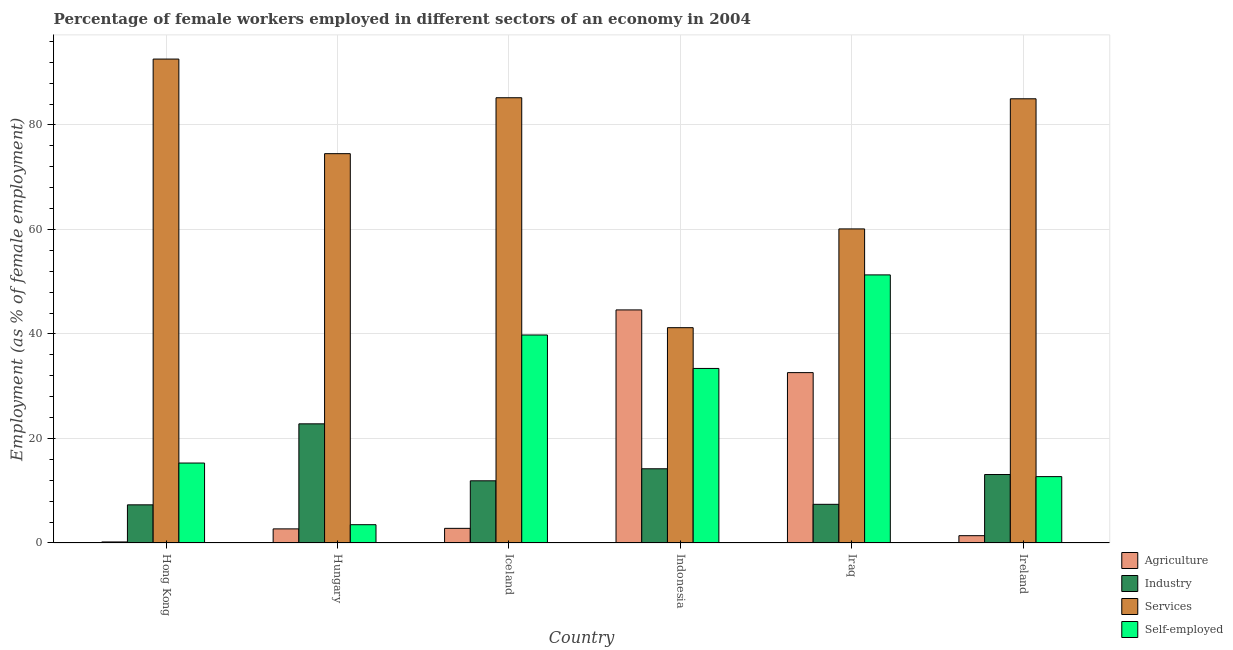How many different coloured bars are there?
Provide a short and direct response. 4. How many groups of bars are there?
Provide a succinct answer. 6. Are the number of bars on each tick of the X-axis equal?
Make the answer very short. Yes. How many bars are there on the 1st tick from the left?
Make the answer very short. 4. What is the label of the 1st group of bars from the left?
Give a very brief answer. Hong Kong. What is the percentage of female workers in agriculture in Hungary?
Offer a terse response. 2.7. Across all countries, what is the maximum percentage of female workers in industry?
Give a very brief answer. 22.8. Across all countries, what is the minimum percentage of female workers in services?
Provide a short and direct response. 41.2. In which country was the percentage of self employed female workers maximum?
Your answer should be compact. Iraq. In which country was the percentage of female workers in agriculture minimum?
Provide a succinct answer. Hong Kong. What is the total percentage of self employed female workers in the graph?
Keep it short and to the point. 156. What is the difference between the percentage of female workers in agriculture in Hungary and that in Ireland?
Offer a terse response. 1.3. What is the difference between the percentage of female workers in agriculture in Indonesia and the percentage of self employed female workers in Hungary?
Provide a succinct answer. 41.1. What is the average percentage of female workers in services per country?
Offer a very short reply. 73.1. What is the difference between the percentage of female workers in agriculture and percentage of self employed female workers in Iraq?
Provide a short and direct response. -18.7. In how many countries, is the percentage of female workers in services greater than 80 %?
Your response must be concise. 3. What is the ratio of the percentage of female workers in agriculture in Indonesia to that in Ireland?
Your answer should be very brief. 31.86. What is the difference between the highest and the lowest percentage of female workers in services?
Provide a short and direct response. 51.4. What does the 1st bar from the left in Ireland represents?
Offer a very short reply. Agriculture. What does the 3rd bar from the right in Ireland represents?
Offer a terse response. Industry. Is it the case that in every country, the sum of the percentage of female workers in agriculture and percentage of female workers in industry is greater than the percentage of female workers in services?
Provide a succinct answer. No. Are all the bars in the graph horizontal?
Provide a succinct answer. No. How many countries are there in the graph?
Your answer should be very brief. 6. What is the difference between two consecutive major ticks on the Y-axis?
Offer a terse response. 20. Are the values on the major ticks of Y-axis written in scientific E-notation?
Make the answer very short. No. Does the graph contain any zero values?
Your answer should be very brief. No. How many legend labels are there?
Offer a terse response. 4. How are the legend labels stacked?
Offer a very short reply. Vertical. What is the title of the graph?
Your answer should be compact. Percentage of female workers employed in different sectors of an economy in 2004. Does "Permission" appear as one of the legend labels in the graph?
Give a very brief answer. No. What is the label or title of the X-axis?
Offer a very short reply. Country. What is the label or title of the Y-axis?
Provide a succinct answer. Employment (as % of female employment). What is the Employment (as % of female employment) in Agriculture in Hong Kong?
Your answer should be compact. 0.2. What is the Employment (as % of female employment) of Industry in Hong Kong?
Offer a terse response. 7.3. What is the Employment (as % of female employment) in Services in Hong Kong?
Offer a terse response. 92.6. What is the Employment (as % of female employment) in Self-employed in Hong Kong?
Offer a terse response. 15.3. What is the Employment (as % of female employment) of Agriculture in Hungary?
Your answer should be compact. 2.7. What is the Employment (as % of female employment) in Industry in Hungary?
Keep it short and to the point. 22.8. What is the Employment (as % of female employment) in Services in Hungary?
Make the answer very short. 74.5. What is the Employment (as % of female employment) in Self-employed in Hungary?
Provide a succinct answer. 3.5. What is the Employment (as % of female employment) in Agriculture in Iceland?
Offer a terse response. 2.8. What is the Employment (as % of female employment) in Industry in Iceland?
Provide a short and direct response. 11.9. What is the Employment (as % of female employment) of Services in Iceland?
Keep it short and to the point. 85.2. What is the Employment (as % of female employment) of Self-employed in Iceland?
Offer a terse response. 39.8. What is the Employment (as % of female employment) in Agriculture in Indonesia?
Your answer should be compact. 44.6. What is the Employment (as % of female employment) of Industry in Indonesia?
Provide a succinct answer. 14.2. What is the Employment (as % of female employment) of Services in Indonesia?
Offer a very short reply. 41.2. What is the Employment (as % of female employment) in Self-employed in Indonesia?
Give a very brief answer. 33.4. What is the Employment (as % of female employment) of Agriculture in Iraq?
Offer a terse response. 32.6. What is the Employment (as % of female employment) of Industry in Iraq?
Provide a short and direct response. 7.4. What is the Employment (as % of female employment) in Services in Iraq?
Provide a short and direct response. 60.1. What is the Employment (as % of female employment) of Self-employed in Iraq?
Ensure brevity in your answer.  51.3. What is the Employment (as % of female employment) in Agriculture in Ireland?
Your response must be concise. 1.4. What is the Employment (as % of female employment) in Industry in Ireland?
Keep it short and to the point. 13.1. What is the Employment (as % of female employment) in Services in Ireland?
Your answer should be very brief. 85. What is the Employment (as % of female employment) in Self-employed in Ireland?
Your answer should be compact. 12.7. Across all countries, what is the maximum Employment (as % of female employment) of Agriculture?
Make the answer very short. 44.6. Across all countries, what is the maximum Employment (as % of female employment) of Industry?
Keep it short and to the point. 22.8. Across all countries, what is the maximum Employment (as % of female employment) of Services?
Your answer should be very brief. 92.6. Across all countries, what is the maximum Employment (as % of female employment) of Self-employed?
Keep it short and to the point. 51.3. Across all countries, what is the minimum Employment (as % of female employment) of Agriculture?
Your response must be concise. 0.2. Across all countries, what is the minimum Employment (as % of female employment) in Industry?
Provide a succinct answer. 7.3. Across all countries, what is the minimum Employment (as % of female employment) of Services?
Your answer should be compact. 41.2. What is the total Employment (as % of female employment) of Agriculture in the graph?
Offer a terse response. 84.3. What is the total Employment (as % of female employment) of Industry in the graph?
Provide a succinct answer. 76.7. What is the total Employment (as % of female employment) in Services in the graph?
Your answer should be compact. 438.6. What is the total Employment (as % of female employment) of Self-employed in the graph?
Give a very brief answer. 156. What is the difference between the Employment (as % of female employment) of Agriculture in Hong Kong and that in Hungary?
Provide a succinct answer. -2.5. What is the difference between the Employment (as % of female employment) of Industry in Hong Kong and that in Hungary?
Offer a very short reply. -15.5. What is the difference between the Employment (as % of female employment) in Agriculture in Hong Kong and that in Iceland?
Make the answer very short. -2.6. What is the difference between the Employment (as % of female employment) of Services in Hong Kong and that in Iceland?
Make the answer very short. 7.4. What is the difference between the Employment (as % of female employment) in Self-employed in Hong Kong and that in Iceland?
Offer a terse response. -24.5. What is the difference between the Employment (as % of female employment) of Agriculture in Hong Kong and that in Indonesia?
Provide a succinct answer. -44.4. What is the difference between the Employment (as % of female employment) of Services in Hong Kong and that in Indonesia?
Provide a succinct answer. 51.4. What is the difference between the Employment (as % of female employment) of Self-employed in Hong Kong and that in Indonesia?
Provide a succinct answer. -18.1. What is the difference between the Employment (as % of female employment) in Agriculture in Hong Kong and that in Iraq?
Keep it short and to the point. -32.4. What is the difference between the Employment (as % of female employment) in Industry in Hong Kong and that in Iraq?
Make the answer very short. -0.1. What is the difference between the Employment (as % of female employment) in Services in Hong Kong and that in Iraq?
Your response must be concise. 32.5. What is the difference between the Employment (as % of female employment) of Self-employed in Hong Kong and that in Iraq?
Keep it short and to the point. -36. What is the difference between the Employment (as % of female employment) in Agriculture in Hong Kong and that in Ireland?
Your response must be concise. -1.2. What is the difference between the Employment (as % of female employment) in Industry in Hong Kong and that in Ireland?
Offer a very short reply. -5.8. What is the difference between the Employment (as % of female employment) in Services in Hong Kong and that in Ireland?
Ensure brevity in your answer.  7.6. What is the difference between the Employment (as % of female employment) of Self-employed in Hong Kong and that in Ireland?
Provide a succinct answer. 2.6. What is the difference between the Employment (as % of female employment) in Industry in Hungary and that in Iceland?
Ensure brevity in your answer.  10.9. What is the difference between the Employment (as % of female employment) of Self-employed in Hungary and that in Iceland?
Offer a very short reply. -36.3. What is the difference between the Employment (as % of female employment) of Agriculture in Hungary and that in Indonesia?
Your answer should be very brief. -41.9. What is the difference between the Employment (as % of female employment) of Industry in Hungary and that in Indonesia?
Give a very brief answer. 8.6. What is the difference between the Employment (as % of female employment) in Services in Hungary and that in Indonesia?
Give a very brief answer. 33.3. What is the difference between the Employment (as % of female employment) of Self-employed in Hungary and that in Indonesia?
Your response must be concise. -29.9. What is the difference between the Employment (as % of female employment) in Agriculture in Hungary and that in Iraq?
Your answer should be very brief. -29.9. What is the difference between the Employment (as % of female employment) of Services in Hungary and that in Iraq?
Your answer should be compact. 14.4. What is the difference between the Employment (as % of female employment) of Self-employed in Hungary and that in Iraq?
Provide a succinct answer. -47.8. What is the difference between the Employment (as % of female employment) of Agriculture in Hungary and that in Ireland?
Give a very brief answer. 1.3. What is the difference between the Employment (as % of female employment) of Industry in Hungary and that in Ireland?
Ensure brevity in your answer.  9.7. What is the difference between the Employment (as % of female employment) in Agriculture in Iceland and that in Indonesia?
Provide a succinct answer. -41.8. What is the difference between the Employment (as % of female employment) in Industry in Iceland and that in Indonesia?
Keep it short and to the point. -2.3. What is the difference between the Employment (as % of female employment) in Services in Iceland and that in Indonesia?
Keep it short and to the point. 44. What is the difference between the Employment (as % of female employment) in Self-employed in Iceland and that in Indonesia?
Make the answer very short. 6.4. What is the difference between the Employment (as % of female employment) in Agriculture in Iceland and that in Iraq?
Offer a terse response. -29.8. What is the difference between the Employment (as % of female employment) in Services in Iceland and that in Iraq?
Your answer should be compact. 25.1. What is the difference between the Employment (as % of female employment) in Self-employed in Iceland and that in Iraq?
Offer a very short reply. -11.5. What is the difference between the Employment (as % of female employment) of Self-employed in Iceland and that in Ireland?
Keep it short and to the point. 27.1. What is the difference between the Employment (as % of female employment) in Services in Indonesia and that in Iraq?
Provide a short and direct response. -18.9. What is the difference between the Employment (as % of female employment) of Self-employed in Indonesia and that in Iraq?
Offer a terse response. -17.9. What is the difference between the Employment (as % of female employment) in Agriculture in Indonesia and that in Ireland?
Give a very brief answer. 43.2. What is the difference between the Employment (as % of female employment) of Industry in Indonesia and that in Ireland?
Keep it short and to the point. 1.1. What is the difference between the Employment (as % of female employment) in Services in Indonesia and that in Ireland?
Your answer should be very brief. -43.8. What is the difference between the Employment (as % of female employment) of Self-employed in Indonesia and that in Ireland?
Your answer should be very brief. 20.7. What is the difference between the Employment (as % of female employment) in Agriculture in Iraq and that in Ireland?
Your response must be concise. 31.2. What is the difference between the Employment (as % of female employment) of Industry in Iraq and that in Ireland?
Offer a very short reply. -5.7. What is the difference between the Employment (as % of female employment) in Services in Iraq and that in Ireland?
Provide a short and direct response. -24.9. What is the difference between the Employment (as % of female employment) of Self-employed in Iraq and that in Ireland?
Your answer should be very brief. 38.6. What is the difference between the Employment (as % of female employment) in Agriculture in Hong Kong and the Employment (as % of female employment) in Industry in Hungary?
Ensure brevity in your answer.  -22.6. What is the difference between the Employment (as % of female employment) in Agriculture in Hong Kong and the Employment (as % of female employment) in Services in Hungary?
Keep it short and to the point. -74.3. What is the difference between the Employment (as % of female employment) in Industry in Hong Kong and the Employment (as % of female employment) in Services in Hungary?
Keep it short and to the point. -67.2. What is the difference between the Employment (as % of female employment) in Industry in Hong Kong and the Employment (as % of female employment) in Self-employed in Hungary?
Give a very brief answer. 3.8. What is the difference between the Employment (as % of female employment) of Services in Hong Kong and the Employment (as % of female employment) of Self-employed in Hungary?
Give a very brief answer. 89.1. What is the difference between the Employment (as % of female employment) of Agriculture in Hong Kong and the Employment (as % of female employment) of Industry in Iceland?
Your response must be concise. -11.7. What is the difference between the Employment (as % of female employment) of Agriculture in Hong Kong and the Employment (as % of female employment) of Services in Iceland?
Your answer should be compact. -85. What is the difference between the Employment (as % of female employment) in Agriculture in Hong Kong and the Employment (as % of female employment) in Self-employed in Iceland?
Your answer should be compact. -39.6. What is the difference between the Employment (as % of female employment) of Industry in Hong Kong and the Employment (as % of female employment) of Services in Iceland?
Provide a succinct answer. -77.9. What is the difference between the Employment (as % of female employment) of Industry in Hong Kong and the Employment (as % of female employment) of Self-employed in Iceland?
Ensure brevity in your answer.  -32.5. What is the difference between the Employment (as % of female employment) of Services in Hong Kong and the Employment (as % of female employment) of Self-employed in Iceland?
Offer a very short reply. 52.8. What is the difference between the Employment (as % of female employment) in Agriculture in Hong Kong and the Employment (as % of female employment) in Services in Indonesia?
Ensure brevity in your answer.  -41. What is the difference between the Employment (as % of female employment) in Agriculture in Hong Kong and the Employment (as % of female employment) in Self-employed in Indonesia?
Give a very brief answer. -33.2. What is the difference between the Employment (as % of female employment) of Industry in Hong Kong and the Employment (as % of female employment) of Services in Indonesia?
Your answer should be compact. -33.9. What is the difference between the Employment (as % of female employment) of Industry in Hong Kong and the Employment (as % of female employment) of Self-employed in Indonesia?
Your answer should be compact. -26.1. What is the difference between the Employment (as % of female employment) in Services in Hong Kong and the Employment (as % of female employment) in Self-employed in Indonesia?
Your answer should be very brief. 59.2. What is the difference between the Employment (as % of female employment) in Agriculture in Hong Kong and the Employment (as % of female employment) in Services in Iraq?
Offer a very short reply. -59.9. What is the difference between the Employment (as % of female employment) of Agriculture in Hong Kong and the Employment (as % of female employment) of Self-employed in Iraq?
Your answer should be very brief. -51.1. What is the difference between the Employment (as % of female employment) in Industry in Hong Kong and the Employment (as % of female employment) in Services in Iraq?
Offer a terse response. -52.8. What is the difference between the Employment (as % of female employment) of Industry in Hong Kong and the Employment (as % of female employment) of Self-employed in Iraq?
Provide a succinct answer. -44. What is the difference between the Employment (as % of female employment) in Services in Hong Kong and the Employment (as % of female employment) in Self-employed in Iraq?
Make the answer very short. 41.3. What is the difference between the Employment (as % of female employment) in Agriculture in Hong Kong and the Employment (as % of female employment) in Services in Ireland?
Make the answer very short. -84.8. What is the difference between the Employment (as % of female employment) in Agriculture in Hong Kong and the Employment (as % of female employment) in Self-employed in Ireland?
Your answer should be compact. -12.5. What is the difference between the Employment (as % of female employment) of Industry in Hong Kong and the Employment (as % of female employment) of Services in Ireland?
Give a very brief answer. -77.7. What is the difference between the Employment (as % of female employment) in Services in Hong Kong and the Employment (as % of female employment) in Self-employed in Ireland?
Provide a succinct answer. 79.9. What is the difference between the Employment (as % of female employment) in Agriculture in Hungary and the Employment (as % of female employment) in Services in Iceland?
Your answer should be very brief. -82.5. What is the difference between the Employment (as % of female employment) of Agriculture in Hungary and the Employment (as % of female employment) of Self-employed in Iceland?
Your response must be concise. -37.1. What is the difference between the Employment (as % of female employment) in Industry in Hungary and the Employment (as % of female employment) in Services in Iceland?
Ensure brevity in your answer.  -62.4. What is the difference between the Employment (as % of female employment) in Industry in Hungary and the Employment (as % of female employment) in Self-employed in Iceland?
Give a very brief answer. -17. What is the difference between the Employment (as % of female employment) in Services in Hungary and the Employment (as % of female employment) in Self-employed in Iceland?
Keep it short and to the point. 34.7. What is the difference between the Employment (as % of female employment) in Agriculture in Hungary and the Employment (as % of female employment) in Services in Indonesia?
Give a very brief answer. -38.5. What is the difference between the Employment (as % of female employment) in Agriculture in Hungary and the Employment (as % of female employment) in Self-employed in Indonesia?
Give a very brief answer. -30.7. What is the difference between the Employment (as % of female employment) of Industry in Hungary and the Employment (as % of female employment) of Services in Indonesia?
Your answer should be compact. -18.4. What is the difference between the Employment (as % of female employment) of Services in Hungary and the Employment (as % of female employment) of Self-employed in Indonesia?
Give a very brief answer. 41.1. What is the difference between the Employment (as % of female employment) in Agriculture in Hungary and the Employment (as % of female employment) in Services in Iraq?
Make the answer very short. -57.4. What is the difference between the Employment (as % of female employment) of Agriculture in Hungary and the Employment (as % of female employment) of Self-employed in Iraq?
Provide a short and direct response. -48.6. What is the difference between the Employment (as % of female employment) of Industry in Hungary and the Employment (as % of female employment) of Services in Iraq?
Offer a terse response. -37.3. What is the difference between the Employment (as % of female employment) of Industry in Hungary and the Employment (as % of female employment) of Self-employed in Iraq?
Provide a short and direct response. -28.5. What is the difference between the Employment (as % of female employment) of Services in Hungary and the Employment (as % of female employment) of Self-employed in Iraq?
Offer a very short reply. 23.2. What is the difference between the Employment (as % of female employment) in Agriculture in Hungary and the Employment (as % of female employment) in Industry in Ireland?
Offer a very short reply. -10.4. What is the difference between the Employment (as % of female employment) in Agriculture in Hungary and the Employment (as % of female employment) in Services in Ireland?
Your answer should be very brief. -82.3. What is the difference between the Employment (as % of female employment) of Agriculture in Hungary and the Employment (as % of female employment) of Self-employed in Ireland?
Offer a very short reply. -10. What is the difference between the Employment (as % of female employment) of Industry in Hungary and the Employment (as % of female employment) of Services in Ireland?
Your answer should be compact. -62.2. What is the difference between the Employment (as % of female employment) in Industry in Hungary and the Employment (as % of female employment) in Self-employed in Ireland?
Give a very brief answer. 10.1. What is the difference between the Employment (as % of female employment) in Services in Hungary and the Employment (as % of female employment) in Self-employed in Ireland?
Offer a terse response. 61.8. What is the difference between the Employment (as % of female employment) of Agriculture in Iceland and the Employment (as % of female employment) of Services in Indonesia?
Make the answer very short. -38.4. What is the difference between the Employment (as % of female employment) in Agriculture in Iceland and the Employment (as % of female employment) in Self-employed in Indonesia?
Make the answer very short. -30.6. What is the difference between the Employment (as % of female employment) of Industry in Iceland and the Employment (as % of female employment) of Services in Indonesia?
Ensure brevity in your answer.  -29.3. What is the difference between the Employment (as % of female employment) of Industry in Iceland and the Employment (as % of female employment) of Self-employed in Indonesia?
Ensure brevity in your answer.  -21.5. What is the difference between the Employment (as % of female employment) of Services in Iceland and the Employment (as % of female employment) of Self-employed in Indonesia?
Keep it short and to the point. 51.8. What is the difference between the Employment (as % of female employment) of Agriculture in Iceland and the Employment (as % of female employment) of Industry in Iraq?
Ensure brevity in your answer.  -4.6. What is the difference between the Employment (as % of female employment) in Agriculture in Iceland and the Employment (as % of female employment) in Services in Iraq?
Your answer should be compact. -57.3. What is the difference between the Employment (as % of female employment) of Agriculture in Iceland and the Employment (as % of female employment) of Self-employed in Iraq?
Offer a terse response. -48.5. What is the difference between the Employment (as % of female employment) of Industry in Iceland and the Employment (as % of female employment) of Services in Iraq?
Offer a terse response. -48.2. What is the difference between the Employment (as % of female employment) in Industry in Iceland and the Employment (as % of female employment) in Self-employed in Iraq?
Provide a succinct answer. -39.4. What is the difference between the Employment (as % of female employment) of Services in Iceland and the Employment (as % of female employment) of Self-employed in Iraq?
Provide a short and direct response. 33.9. What is the difference between the Employment (as % of female employment) of Agriculture in Iceland and the Employment (as % of female employment) of Industry in Ireland?
Provide a short and direct response. -10.3. What is the difference between the Employment (as % of female employment) of Agriculture in Iceland and the Employment (as % of female employment) of Services in Ireland?
Keep it short and to the point. -82.2. What is the difference between the Employment (as % of female employment) of Agriculture in Iceland and the Employment (as % of female employment) of Self-employed in Ireland?
Offer a very short reply. -9.9. What is the difference between the Employment (as % of female employment) in Industry in Iceland and the Employment (as % of female employment) in Services in Ireland?
Your response must be concise. -73.1. What is the difference between the Employment (as % of female employment) of Services in Iceland and the Employment (as % of female employment) of Self-employed in Ireland?
Offer a very short reply. 72.5. What is the difference between the Employment (as % of female employment) in Agriculture in Indonesia and the Employment (as % of female employment) in Industry in Iraq?
Make the answer very short. 37.2. What is the difference between the Employment (as % of female employment) in Agriculture in Indonesia and the Employment (as % of female employment) in Services in Iraq?
Provide a short and direct response. -15.5. What is the difference between the Employment (as % of female employment) in Industry in Indonesia and the Employment (as % of female employment) in Services in Iraq?
Give a very brief answer. -45.9. What is the difference between the Employment (as % of female employment) of Industry in Indonesia and the Employment (as % of female employment) of Self-employed in Iraq?
Make the answer very short. -37.1. What is the difference between the Employment (as % of female employment) in Services in Indonesia and the Employment (as % of female employment) in Self-employed in Iraq?
Give a very brief answer. -10.1. What is the difference between the Employment (as % of female employment) in Agriculture in Indonesia and the Employment (as % of female employment) in Industry in Ireland?
Your response must be concise. 31.5. What is the difference between the Employment (as % of female employment) in Agriculture in Indonesia and the Employment (as % of female employment) in Services in Ireland?
Provide a succinct answer. -40.4. What is the difference between the Employment (as % of female employment) of Agriculture in Indonesia and the Employment (as % of female employment) of Self-employed in Ireland?
Ensure brevity in your answer.  31.9. What is the difference between the Employment (as % of female employment) in Industry in Indonesia and the Employment (as % of female employment) in Services in Ireland?
Provide a short and direct response. -70.8. What is the difference between the Employment (as % of female employment) of Services in Indonesia and the Employment (as % of female employment) of Self-employed in Ireland?
Provide a succinct answer. 28.5. What is the difference between the Employment (as % of female employment) of Agriculture in Iraq and the Employment (as % of female employment) of Services in Ireland?
Ensure brevity in your answer.  -52.4. What is the difference between the Employment (as % of female employment) of Agriculture in Iraq and the Employment (as % of female employment) of Self-employed in Ireland?
Your response must be concise. 19.9. What is the difference between the Employment (as % of female employment) in Industry in Iraq and the Employment (as % of female employment) in Services in Ireland?
Offer a very short reply. -77.6. What is the difference between the Employment (as % of female employment) in Industry in Iraq and the Employment (as % of female employment) in Self-employed in Ireland?
Provide a succinct answer. -5.3. What is the difference between the Employment (as % of female employment) in Services in Iraq and the Employment (as % of female employment) in Self-employed in Ireland?
Offer a terse response. 47.4. What is the average Employment (as % of female employment) in Agriculture per country?
Give a very brief answer. 14.05. What is the average Employment (as % of female employment) of Industry per country?
Provide a short and direct response. 12.78. What is the average Employment (as % of female employment) in Services per country?
Make the answer very short. 73.1. What is the difference between the Employment (as % of female employment) in Agriculture and Employment (as % of female employment) in Services in Hong Kong?
Provide a succinct answer. -92.4. What is the difference between the Employment (as % of female employment) of Agriculture and Employment (as % of female employment) of Self-employed in Hong Kong?
Give a very brief answer. -15.1. What is the difference between the Employment (as % of female employment) in Industry and Employment (as % of female employment) in Services in Hong Kong?
Your answer should be compact. -85.3. What is the difference between the Employment (as % of female employment) of Industry and Employment (as % of female employment) of Self-employed in Hong Kong?
Keep it short and to the point. -8. What is the difference between the Employment (as % of female employment) in Services and Employment (as % of female employment) in Self-employed in Hong Kong?
Keep it short and to the point. 77.3. What is the difference between the Employment (as % of female employment) of Agriculture and Employment (as % of female employment) of Industry in Hungary?
Provide a succinct answer. -20.1. What is the difference between the Employment (as % of female employment) of Agriculture and Employment (as % of female employment) of Services in Hungary?
Provide a succinct answer. -71.8. What is the difference between the Employment (as % of female employment) of Agriculture and Employment (as % of female employment) of Self-employed in Hungary?
Keep it short and to the point. -0.8. What is the difference between the Employment (as % of female employment) in Industry and Employment (as % of female employment) in Services in Hungary?
Ensure brevity in your answer.  -51.7. What is the difference between the Employment (as % of female employment) of Industry and Employment (as % of female employment) of Self-employed in Hungary?
Your answer should be very brief. 19.3. What is the difference between the Employment (as % of female employment) of Agriculture and Employment (as % of female employment) of Industry in Iceland?
Your answer should be compact. -9.1. What is the difference between the Employment (as % of female employment) of Agriculture and Employment (as % of female employment) of Services in Iceland?
Offer a very short reply. -82.4. What is the difference between the Employment (as % of female employment) in Agriculture and Employment (as % of female employment) in Self-employed in Iceland?
Your answer should be compact. -37. What is the difference between the Employment (as % of female employment) of Industry and Employment (as % of female employment) of Services in Iceland?
Give a very brief answer. -73.3. What is the difference between the Employment (as % of female employment) in Industry and Employment (as % of female employment) in Self-employed in Iceland?
Make the answer very short. -27.9. What is the difference between the Employment (as % of female employment) of Services and Employment (as % of female employment) of Self-employed in Iceland?
Make the answer very short. 45.4. What is the difference between the Employment (as % of female employment) of Agriculture and Employment (as % of female employment) of Industry in Indonesia?
Offer a terse response. 30.4. What is the difference between the Employment (as % of female employment) of Agriculture and Employment (as % of female employment) of Services in Indonesia?
Offer a terse response. 3.4. What is the difference between the Employment (as % of female employment) of Agriculture and Employment (as % of female employment) of Self-employed in Indonesia?
Make the answer very short. 11.2. What is the difference between the Employment (as % of female employment) of Industry and Employment (as % of female employment) of Services in Indonesia?
Keep it short and to the point. -27. What is the difference between the Employment (as % of female employment) in Industry and Employment (as % of female employment) in Self-employed in Indonesia?
Keep it short and to the point. -19.2. What is the difference between the Employment (as % of female employment) in Services and Employment (as % of female employment) in Self-employed in Indonesia?
Ensure brevity in your answer.  7.8. What is the difference between the Employment (as % of female employment) of Agriculture and Employment (as % of female employment) of Industry in Iraq?
Offer a very short reply. 25.2. What is the difference between the Employment (as % of female employment) in Agriculture and Employment (as % of female employment) in Services in Iraq?
Provide a short and direct response. -27.5. What is the difference between the Employment (as % of female employment) of Agriculture and Employment (as % of female employment) of Self-employed in Iraq?
Your answer should be compact. -18.7. What is the difference between the Employment (as % of female employment) of Industry and Employment (as % of female employment) of Services in Iraq?
Offer a terse response. -52.7. What is the difference between the Employment (as % of female employment) of Industry and Employment (as % of female employment) of Self-employed in Iraq?
Offer a terse response. -43.9. What is the difference between the Employment (as % of female employment) of Services and Employment (as % of female employment) of Self-employed in Iraq?
Provide a succinct answer. 8.8. What is the difference between the Employment (as % of female employment) of Agriculture and Employment (as % of female employment) of Industry in Ireland?
Your response must be concise. -11.7. What is the difference between the Employment (as % of female employment) of Agriculture and Employment (as % of female employment) of Services in Ireland?
Your answer should be compact. -83.6. What is the difference between the Employment (as % of female employment) of Industry and Employment (as % of female employment) of Services in Ireland?
Your answer should be very brief. -71.9. What is the difference between the Employment (as % of female employment) of Industry and Employment (as % of female employment) of Self-employed in Ireland?
Offer a terse response. 0.4. What is the difference between the Employment (as % of female employment) in Services and Employment (as % of female employment) in Self-employed in Ireland?
Ensure brevity in your answer.  72.3. What is the ratio of the Employment (as % of female employment) of Agriculture in Hong Kong to that in Hungary?
Keep it short and to the point. 0.07. What is the ratio of the Employment (as % of female employment) of Industry in Hong Kong to that in Hungary?
Your response must be concise. 0.32. What is the ratio of the Employment (as % of female employment) of Services in Hong Kong to that in Hungary?
Provide a succinct answer. 1.24. What is the ratio of the Employment (as % of female employment) in Self-employed in Hong Kong to that in Hungary?
Your answer should be very brief. 4.37. What is the ratio of the Employment (as % of female employment) in Agriculture in Hong Kong to that in Iceland?
Ensure brevity in your answer.  0.07. What is the ratio of the Employment (as % of female employment) in Industry in Hong Kong to that in Iceland?
Your response must be concise. 0.61. What is the ratio of the Employment (as % of female employment) of Services in Hong Kong to that in Iceland?
Your answer should be very brief. 1.09. What is the ratio of the Employment (as % of female employment) of Self-employed in Hong Kong to that in Iceland?
Your answer should be compact. 0.38. What is the ratio of the Employment (as % of female employment) in Agriculture in Hong Kong to that in Indonesia?
Your response must be concise. 0. What is the ratio of the Employment (as % of female employment) of Industry in Hong Kong to that in Indonesia?
Your answer should be very brief. 0.51. What is the ratio of the Employment (as % of female employment) of Services in Hong Kong to that in Indonesia?
Ensure brevity in your answer.  2.25. What is the ratio of the Employment (as % of female employment) of Self-employed in Hong Kong to that in Indonesia?
Keep it short and to the point. 0.46. What is the ratio of the Employment (as % of female employment) of Agriculture in Hong Kong to that in Iraq?
Make the answer very short. 0.01. What is the ratio of the Employment (as % of female employment) in Industry in Hong Kong to that in Iraq?
Your answer should be very brief. 0.99. What is the ratio of the Employment (as % of female employment) in Services in Hong Kong to that in Iraq?
Offer a terse response. 1.54. What is the ratio of the Employment (as % of female employment) in Self-employed in Hong Kong to that in Iraq?
Offer a terse response. 0.3. What is the ratio of the Employment (as % of female employment) in Agriculture in Hong Kong to that in Ireland?
Your answer should be compact. 0.14. What is the ratio of the Employment (as % of female employment) of Industry in Hong Kong to that in Ireland?
Give a very brief answer. 0.56. What is the ratio of the Employment (as % of female employment) in Services in Hong Kong to that in Ireland?
Keep it short and to the point. 1.09. What is the ratio of the Employment (as % of female employment) in Self-employed in Hong Kong to that in Ireland?
Give a very brief answer. 1.2. What is the ratio of the Employment (as % of female employment) of Industry in Hungary to that in Iceland?
Provide a short and direct response. 1.92. What is the ratio of the Employment (as % of female employment) of Services in Hungary to that in Iceland?
Ensure brevity in your answer.  0.87. What is the ratio of the Employment (as % of female employment) in Self-employed in Hungary to that in Iceland?
Provide a succinct answer. 0.09. What is the ratio of the Employment (as % of female employment) of Agriculture in Hungary to that in Indonesia?
Provide a succinct answer. 0.06. What is the ratio of the Employment (as % of female employment) of Industry in Hungary to that in Indonesia?
Your answer should be compact. 1.61. What is the ratio of the Employment (as % of female employment) in Services in Hungary to that in Indonesia?
Give a very brief answer. 1.81. What is the ratio of the Employment (as % of female employment) in Self-employed in Hungary to that in Indonesia?
Keep it short and to the point. 0.1. What is the ratio of the Employment (as % of female employment) of Agriculture in Hungary to that in Iraq?
Your answer should be very brief. 0.08. What is the ratio of the Employment (as % of female employment) of Industry in Hungary to that in Iraq?
Your answer should be very brief. 3.08. What is the ratio of the Employment (as % of female employment) in Services in Hungary to that in Iraq?
Ensure brevity in your answer.  1.24. What is the ratio of the Employment (as % of female employment) of Self-employed in Hungary to that in Iraq?
Your answer should be very brief. 0.07. What is the ratio of the Employment (as % of female employment) in Agriculture in Hungary to that in Ireland?
Give a very brief answer. 1.93. What is the ratio of the Employment (as % of female employment) in Industry in Hungary to that in Ireland?
Your response must be concise. 1.74. What is the ratio of the Employment (as % of female employment) of Services in Hungary to that in Ireland?
Offer a terse response. 0.88. What is the ratio of the Employment (as % of female employment) of Self-employed in Hungary to that in Ireland?
Make the answer very short. 0.28. What is the ratio of the Employment (as % of female employment) in Agriculture in Iceland to that in Indonesia?
Offer a terse response. 0.06. What is the ratio of the Employment (as % of female employment) of Industry in Iceland to that in Indonesia?
Your answer should be very brief. 0.84. What is the ratio of the Employment (as % of female employment) in Services in Iceland to that in Indonesia?
Provide a short and direct response. 2.07. What is the ratio of the Employment (as % of female employment) in Self-employed in Iceland to that in Indonesia?
Ensure brevity in your answer.  1.19. What is the ratio of the Employment (as % of female employment) of Agriculture in Iceland to that in Iraq?
Your response must be concise. 0.09. What is the ratio of the Employment (as % of female employment) in Industry in Iceland to that in Iraq?
Provide a succinct answer. 1.61. What is the ratio of the Employment (as % of female employment) in Services in Iceland to that in Iraq?
Make the answer very short. 1.42. What is the ratio of the Employment (as % of female employment) in Self-employed in Iceland to that in Iraq?
Provide a short and direct response. 0.78. What is the ratio of the Employment (as % of female employment) in Industry in Iceland to that in Ireland?
Your response must be concise. 0.91. What is the ratio of the Employment (as % of female employment) of Self-employed in Iceland to that in Ireland?
Your answer should be very brief. 3.13. What is the ratio of the Employment (as % of female employment) in Agriculture in Indonesia to that in Iraq?
Your answer should be compact. 1.37. What is the ratio of the Employment (as % of female employment) of Industry in Indonesia to that in Iraq?
Your response must be concise. 1.92. What is the ratio of the Employment (as % of female employment) in Services in Indonesia to that in Iraq?
Your response must be concise. 0.69. What is the ratio of the Employment (as % of female employment) in Self-employed in Indonesia to that in Iraq?
Your answer should be very brief. 0.65. What is the ratio of the Employment (as % of female employment) of Agriculture in Indonesia to that in Ireland?
Offer a terse response. 31.86. What is the ratio of the Employment (as % of female employment) of Industry in Indonesia to that in Ireland?
Your response must be concise. 1.08. What is the ratio of the Employment (as % of female employment) in Services in Indonesia to that in Ireland?
Keep it short and to the point. 0.48. What is the ratio of the Employment (as % of female employment) of Self-employed in Indonesia to that in Ireland?
Give a very brief answer. 2.63. What is the ratio of the Employment (as % of female employment) in Agriculture in Iraq to that in Ireland?
Provide a short and direct response. 23.29. What is the ratio of the Employment (as % of female employment) in Industry in Iraq to that in Ireland?
Offer a very short reply. 0.56. What is the ratio of the Employment (as % of female employment) of Services in Iraq to that in Ireland?
Your answer should be very brief. 0.71. What is the ratio of the Employment (as % of female employment) of Self-employed in Iraq to that in Ireland?
Ensure brevity in your answer.  4.04. What is the difference between the highest and the second highest Employment (as % of female employment) of Agriculture?
Your answer should be very brief. 12. What is the difference between the highest and the second highest Employment (as % of female employment) of Industry?
Provide a succinct answer. 8.6. What is the difference between the highest and the second highest Employment (as % of female employment) of Services?
Your answer should be very brief. 7.4. What is the difference between the highest and the lowest Employment (as % of female employment) in Agriculture?
Provide a succinct answer. 44.4. What is the difference between the highest and the lowest Employment (as % of female employment) of Industry?
Offer a very short reply. 15.5. What is the difference between the highest and the lowest Employment (as % of female employment) of Services?
Your response must be concise. 51.4. What is the difference between the highest and the lowest Employment (as % of female employment) of Self-employed?
Provide a short and direct response. 47.8. 